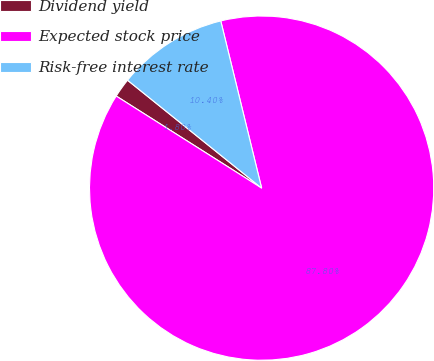Convert chart to OTSL. <chart><loc_0><loc_0><loc_500><loc_500><pie_chart><fcel>Dividend yield<fcel>Expected stock price<fcel>Risk-free interest rate<nl><fcel>1.8%<fcel>87.8%<fcel>10.4%<nl></chart> 